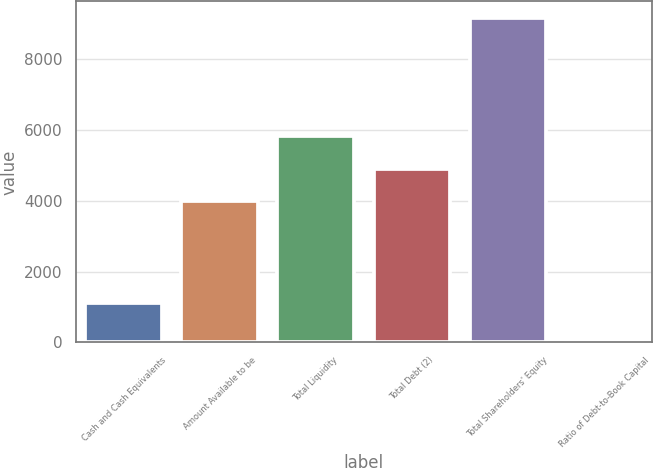Convert chart. <chart><loc_0><loc_0><loc_500><loc_500><bar_chart><fcel>Cash and Cash Equivalents<fcel>Amount Available to be<fcel>Total Liquidity<fcel>Total Debt (2)<fcel>Total Shareholders' Equity<fcel>Ratio of Debt-to-Book Capital<nl><fcel>1117<fcel>4000<fcel>5829.8<fcel>4914.9<fcel>9184<fcel>35<nl></chart> 